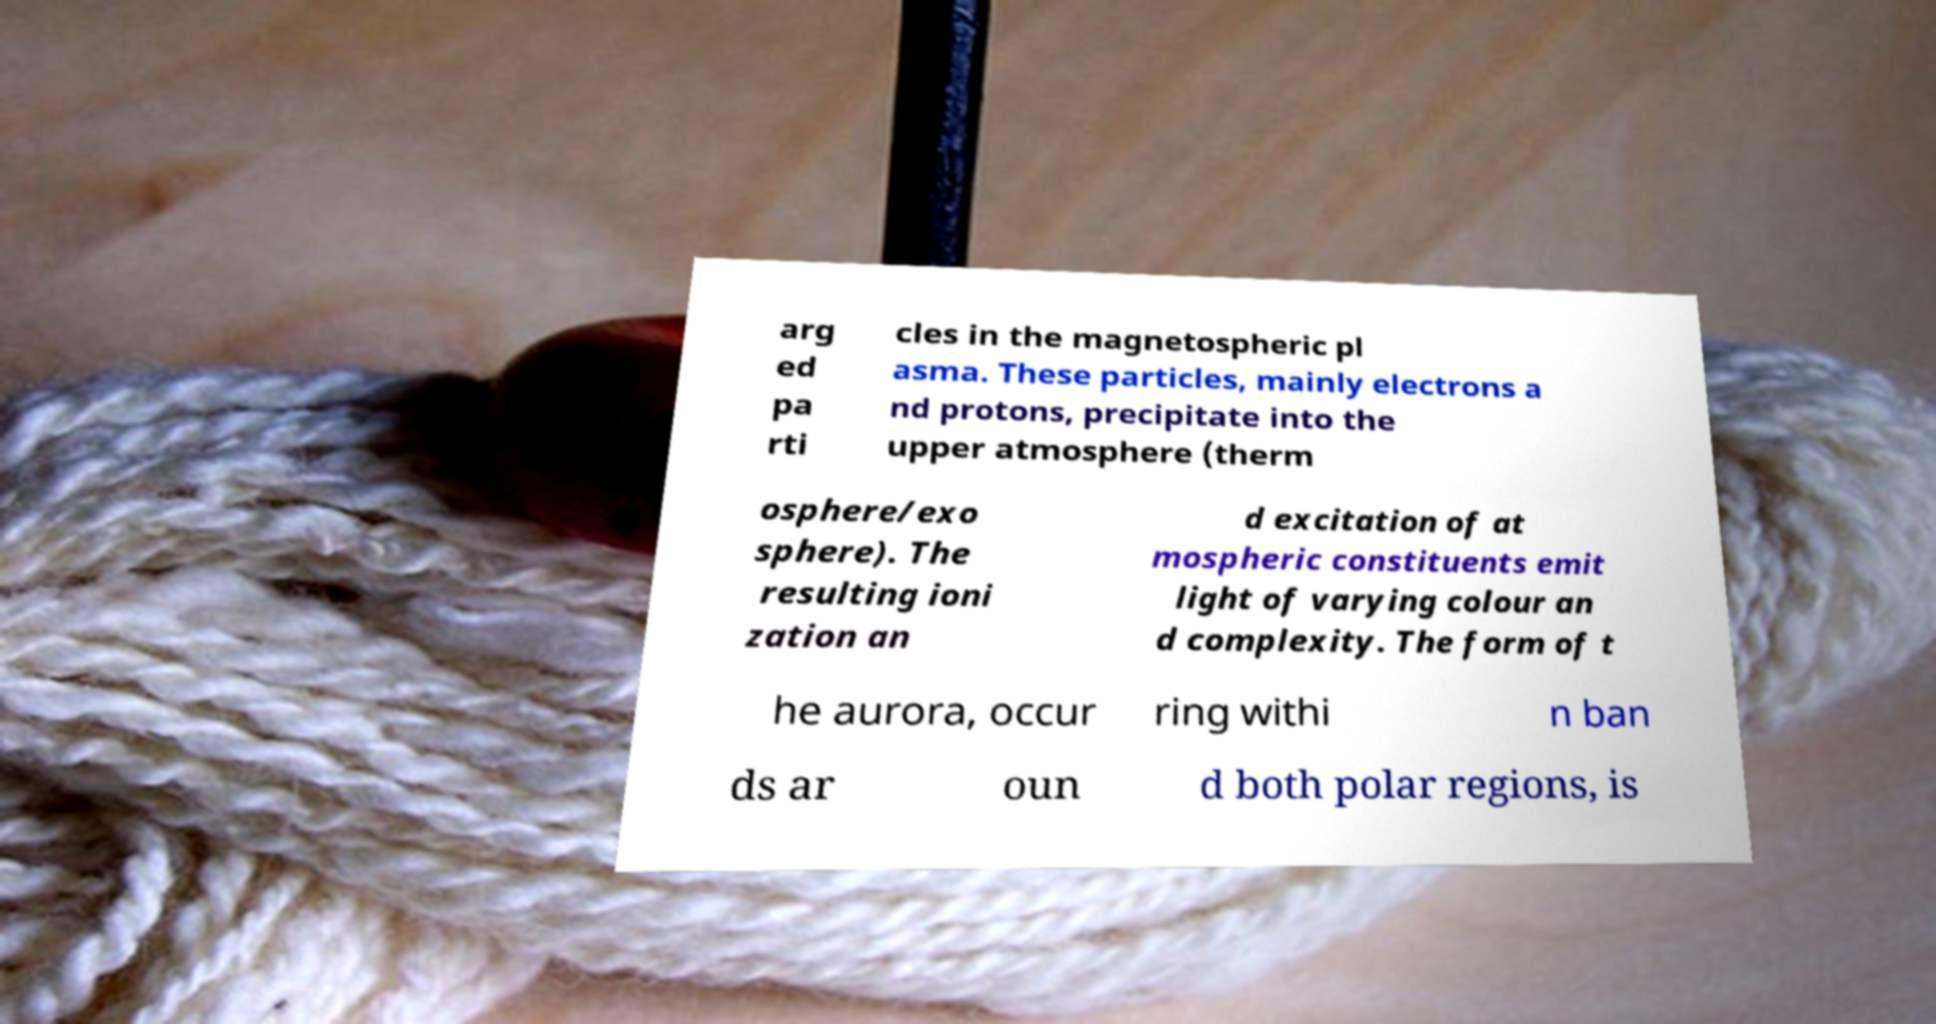What messages or text are displayed in this image? I need them in a readable, typed format. arg ed pa rti cles in the magnetospheric pl asma. These particles, mainly electrons a nd protons, precipitate into the upper atmosphere (therm osphere/exo sphere). The resulting ioni zation an d excitation of at mospheric constituents emit light of varying colour an d complexity. The form of t he aurora, occur ring withi n ban ds ar oun d both polar regions, is 